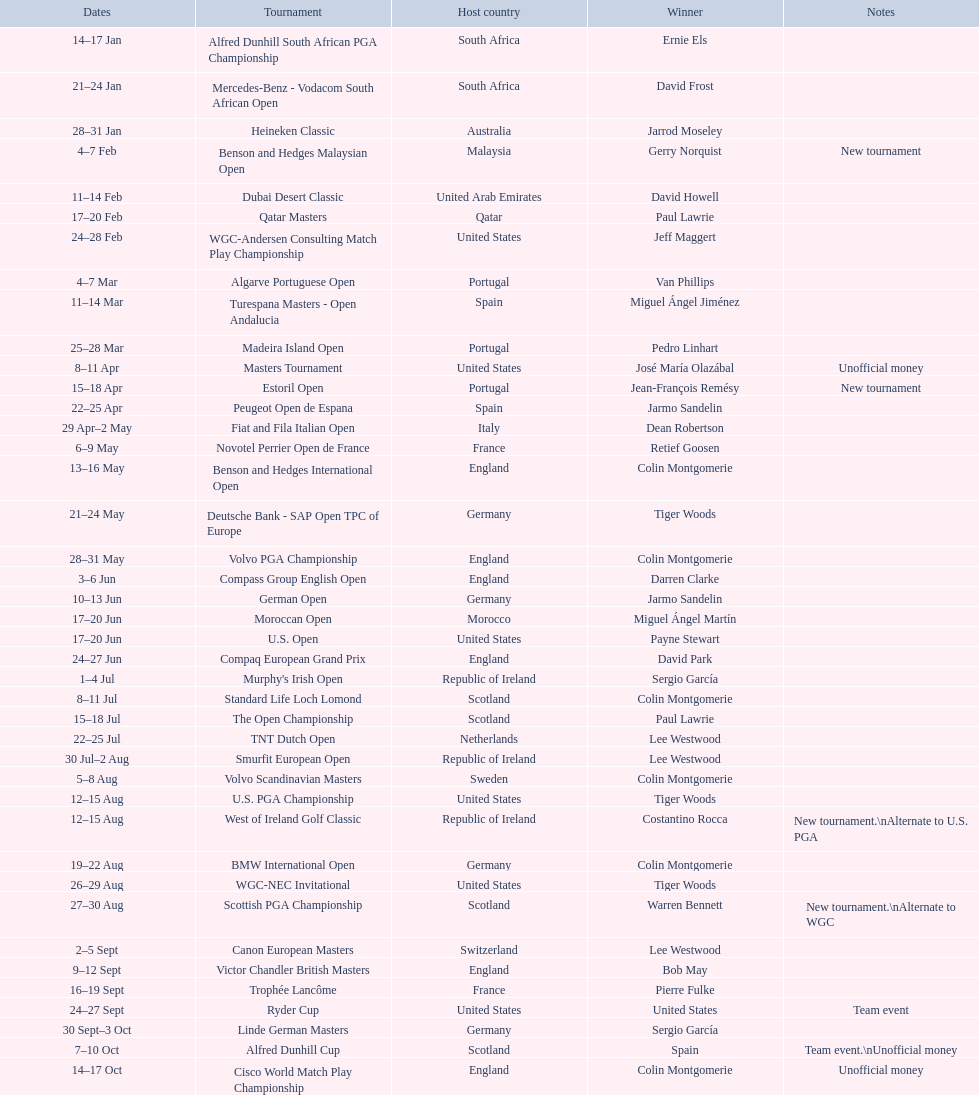Which country was mentioned when a new tournament was first introduced? Malaysia. 